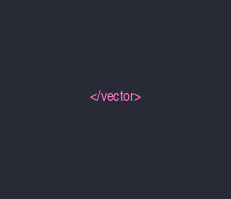Convert code to text. <code><loc_0><loc_0><loc_500><loc_500><_XML_></vector></code> 